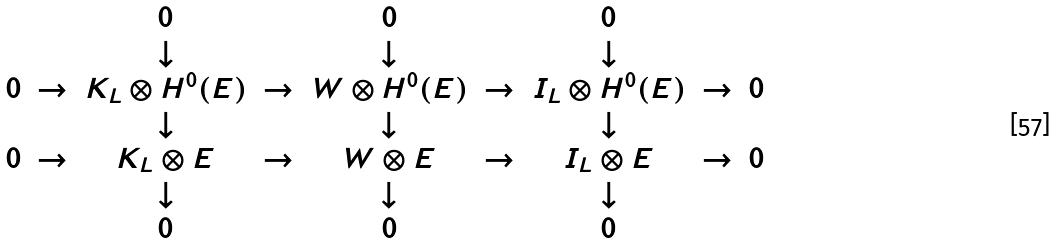<formula> <loc_0><loc_0><loc_500><loc_500>\begin{array} { c c c c c c c c c } & & 0 & & 0 & & 0 & & \\ & & \downarrow & & \downarrow & & \downarrow & & \\ 0 & \rightarrow & K _ { L } \otimes H ^ { 0 } ( E ) & \rightarrow & W \otimes H ^ { 0 } ( E ) & { \rightarrow } & I _ { L } \otimes H ^ { 0 } ( E ) & \rightarrow & 0 \\ & & \downarrow & & \downarrow & & \downarrow & & \\ 0 & \rightarrow & K _ { L } \otimes E & \rightarrow & W \otimes E & { \rightarrow } & I _ { L } \otimes E & \rightarrow & 0 \\ & & \downarrow & & \downarrow & & \downarrow & & \\ & & 0 & & 0 & & 0 & & \\ \end{array}</formula> 